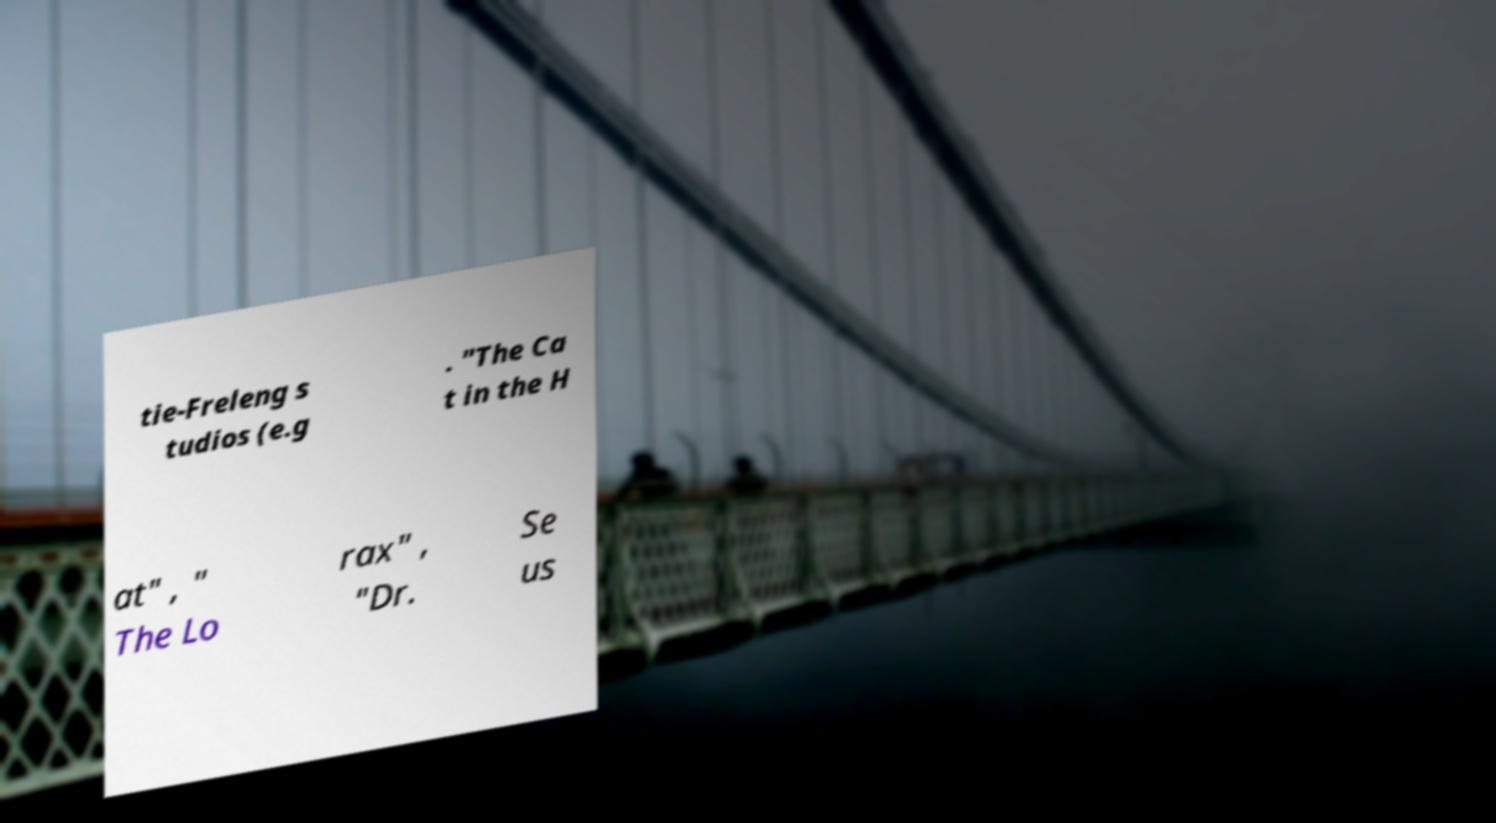Please identify and transcribe the text found in this image. tie-Freleng s tudios (e.g . "The Ca t in the H at" , " The Lo rax" , "Dr. Se us 